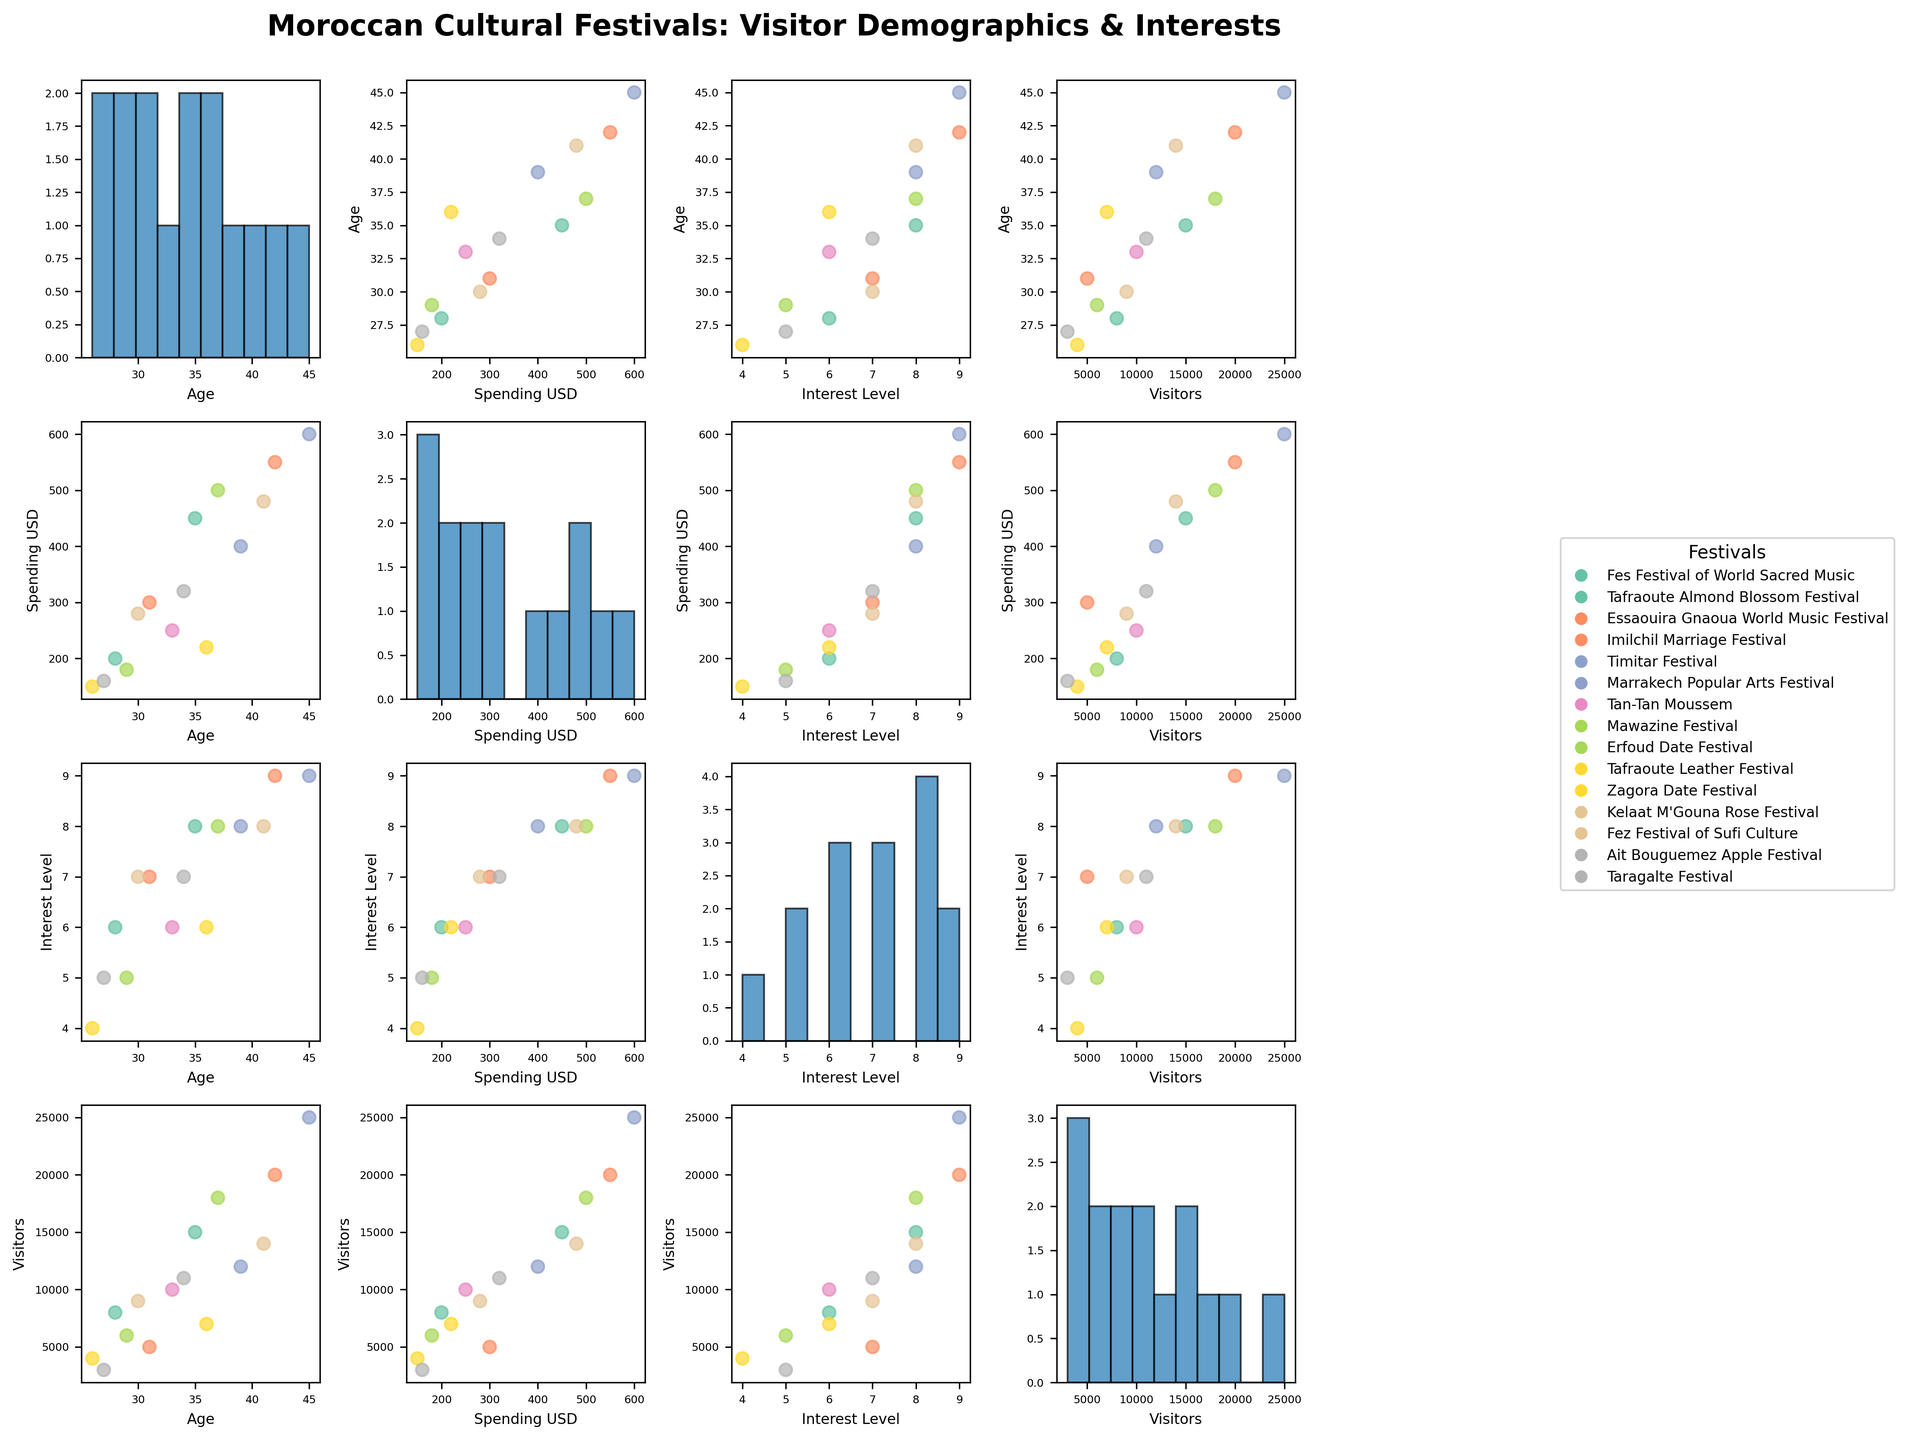What is the title of the scatterplot matrix? The title can be found at the top of the figure.
Answer: Moroccan Cultural Festivals: Visitor Demographics & Interests Which festival has the highest visitor count and what is the count? Locate the point with the maximum value on the "Visitors" axis and identify the corresponding festival name.
Answer: Marrakech Popular Arts Festival with 25,000 visitors What is the average spending (in USD) of visitors across all festivals? Sum all the spending values and divide by the number of festivals. (450 + 200 + 550 + 300 + 400 + 600 + 250 + 500 + 180 + 150 + 220 + 280 + 480 + 160 + 320) / 15 = 374 USD
Answer: 374 USD Which festival has a visitor age closest to 35 years old? Find the point on the "Age" axis that is closest to 35 and identify the corresponding festival name.
Answer: Fes Festival of World Sacred Music Is there a strong correlation between visitor age and spending? Observe the scatter plot for the "Age" vs "Spending_USD" combination. If the points are closely clustered around a line, there is a strong correlation.
Answer: No, there is no strong correlation Which two festivals have visitors with the highest interest levels and what are they? Identify the top two points on the "Interest_Level" histogram or scatter plots.
Answer: Marrakech Popular Arts Festival and Essaouira Gnaoua World Music Festival, both with interest level 9 What is the range of visitor spending for the Fez Festival of Sufi Culture? Look at the "Spending_USD" axis where the Fez Festival of Sufi Culture plots are shown.
Answer: 480 USD Do festivals with higher visitor counts tend to have higher spending? Examine the scatter plot comparing "Visitors" to "Spending_USD". If data points with high visitor counts generally align with high spending, then yes.
Answer: Yes, generally What is the median interest level across all festivals? Order the interest levels and find the middle value. Sorted list: 4, 5, 5, 6, 6, 6, 7, 7, 7, 8, 8, 8, 8, 9, 9. Median is the 8th value.
Answer: 7 Which festival shows the lowest visitor count and what is this count? Identify the point with the smallest value on the "Visitors" axis and find the corresponding festival name.
Answer: Ait Bouguemez Apple Festival with 3,000 visitors 